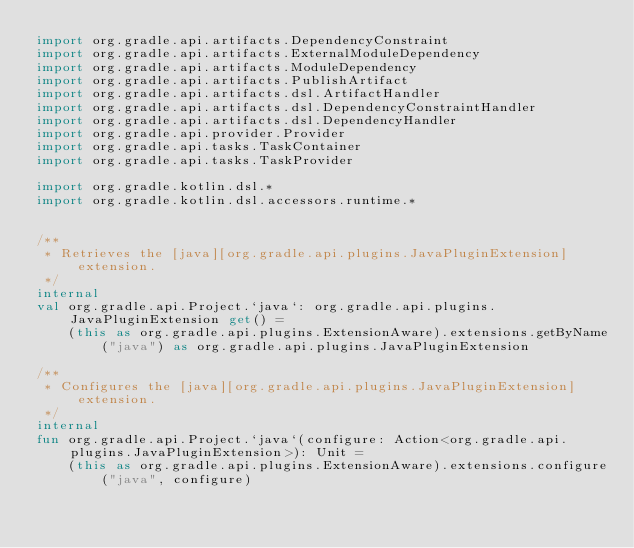<code> <loc_0><loc_0><loc_500><loc_500><_Kotlin_>import org.gradle.api.artifacts.DependencyConstraint
import org.gradle.api.artifacts.ExternalModuleDependency
import org.gradle.api.artifacts.ModuleDependency
import org.gradle.api.artifacts.PublishArtifact
import org.gradle.api.artifacts.dsl.ArtifactHandler
import org.gradle.api.artifacts.dsl.DependencyConstraintHandler
import org.gradle.api.artifacts.dsl.DependencyHandler
import org.gradle.api.provider.Provider
import org.gradle.api.tasks.TaskContainer
import org.gradle.api.tasks.TaskProvider

import org.gradle.kotlin.dsl.*
import org.gradle.kotlin.dsl.accessors.runtime.*


/**
 * Retrieves the [java][org.gradle.api.plugins.JavaPluginExtension] extension.
 */
internal
val org.gradle.api.Project.`java`: org.gradle.api.plugins.JavaPluginExtension get() =
    (this as org.gradle.api.plugins.ExtensionAware).extensions.getByName("java") as org.gradle.api.plugins.JavaPluginExtension

/**
 * Configures the [java][org.gradle.api.plugins.JavaPluginExtension] extension.
 */
internal
fun org.gradle.api.Project.`java`(configure: Action<org.gradle.api.plugins.JavaPluginExtension>): Unit =
    (this as org.gradle.api.plugins.ExtensionAware).extensions.configure("java", configure)



</code> 